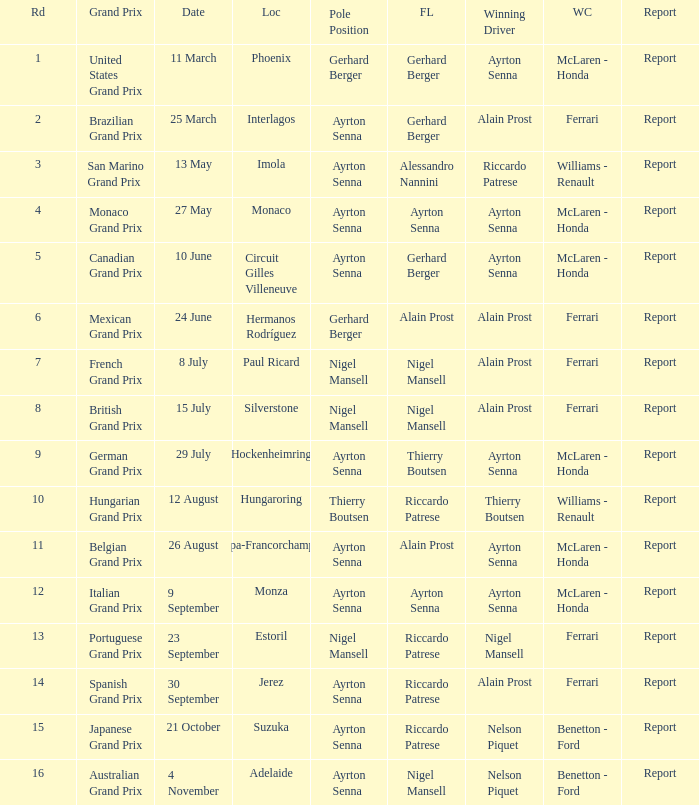What is the Pole Position for the German Grand Prix Ayrton Senna. 